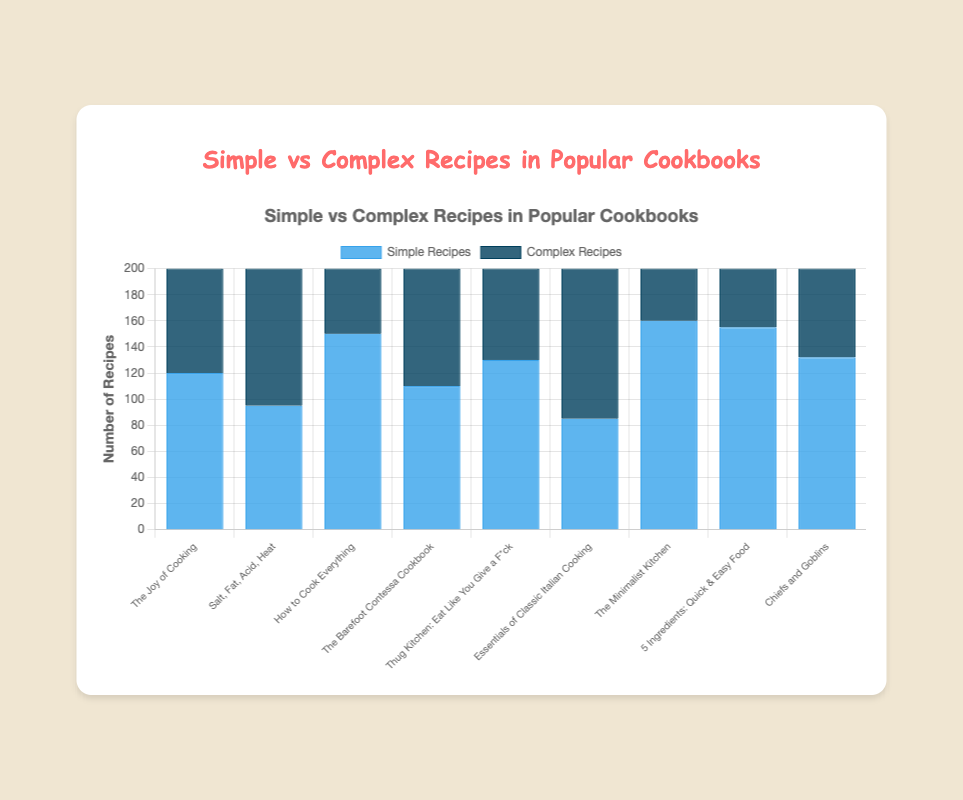Which cookbook has the highest number of simple recipes? Look at the heights of the blue bars representing simple recipes for all cookbooks. "The Minimalist Kitchen" has the tallest bar.
Answer: The Minimalist Kitchen Which cookbook contains more complex recipes than simple recipes? Identify the cookbooks where the height of the dark blue bar (complex recipes) is taller than the blue bar (simple recipes). Only "Salt, Fat, Acid, Heat" and "Essentials of Classic Italian Cooking" meet this criterion.
Answer: Salt, Fat, Acid, Heat and Essentials of Classic Italian Cooking What is the total number of simple recipes in "Thug Kitchen: Eat Like You Give a F*ck" and "The Joy of Cooking"? Sum the simple recipe counts: "Thug Kitchen: Eat Like You Give a F*ck" (130) + "The Joy of Cooking" (120). Adding these, we get 130 + 120 = 250.
Answer: 250 What is the combined number of recipes (simple and complex) in "5 Ingredients: Quick & Easy Food"? Add the number of simple recipes (155) to the number of complex recipes (45). 155 + 45 = 200.
Answer: 200 Which cookbook has the least number of complex recipes? Look at the heights of the dark blue bars representing complex recipes for all cookbooks. "The Minimalist Kitchen" has the shortest bar.
Answer: The Minimalist Kitchen How many more simple recipes are there in "The Barefoot Contessa Cookbook" compared to complex recipes? Subtract the number of complex recipes from the number of simple recipes in "The Barefoot Contessa Cookbook" (110 - 90). 110 - 90 = 20.
Answer: 20 In which cookbook are the number of simple and complex recipes nearly equal? Identify the cookbooks where the heights of the blue and dark blue bars are closest. "Salt, Fat, Acid, Heat" has simple (95) and complex recipes (105), with a small difference of 10.
Answer: Salt, Fat, Acid, Heat 